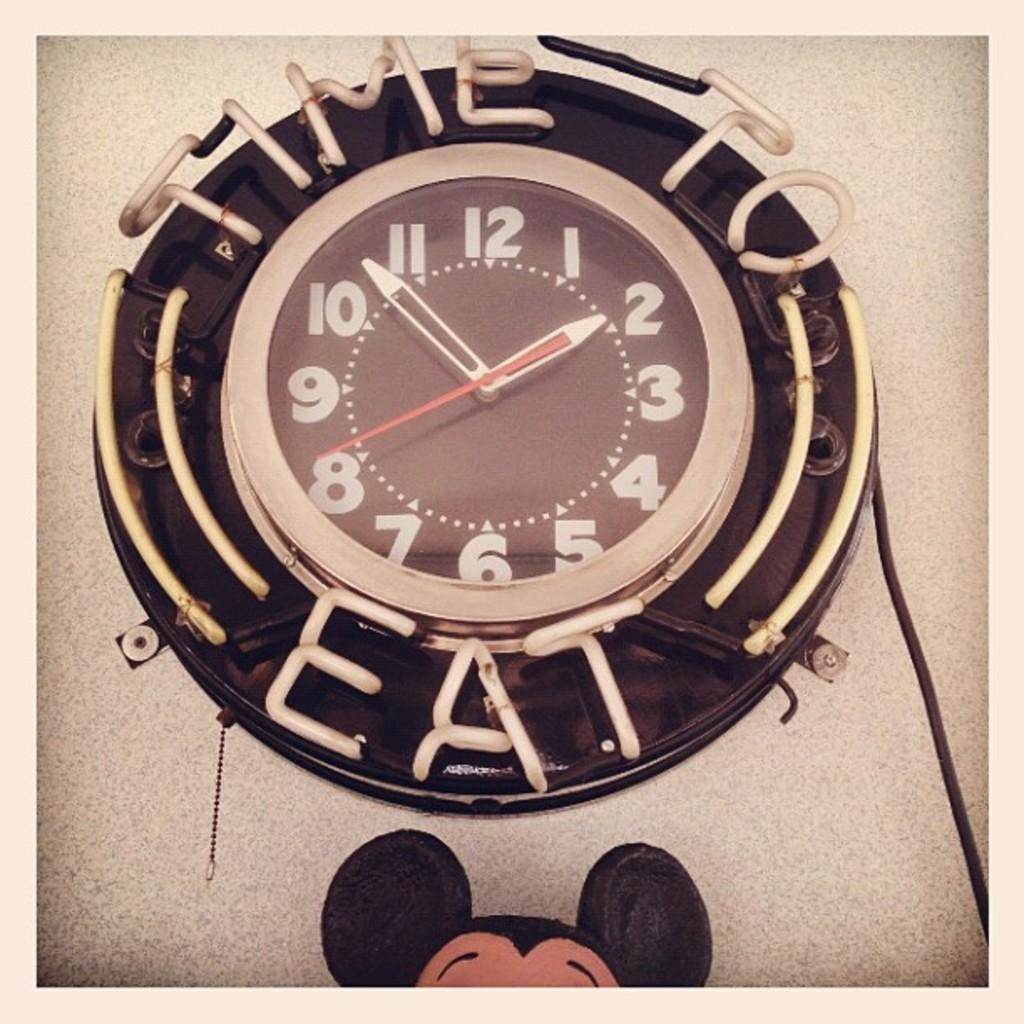<image>
Relay a brief, clear account of the picture shown. A round neon clock that says time to eat around it 